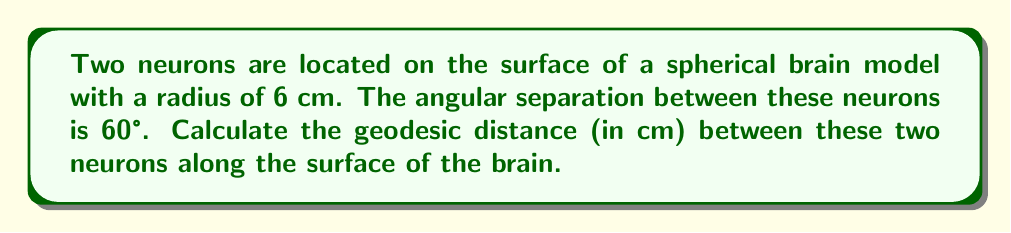Help me with this question. To solve this problem, we'll use the formula for the arc length on a sphere, which represents the geodesic distance between two points on a spherical surface.

Step 1: Recall the formula for arc length (s) on a sphere:
$$s = r\theta$$
Where:
- $r$ is the radius of the sphere
- $\theta$ is the central angle in radians

Step 2: Convert the given angle from degrees to radians:
$$\theta = 60° \times \frac{\pi}{180°} = \frac{\pi}{3} \text{ radians}$$

Step 3: Apply the arc length formula:
$$s = r\theta = 6 \text{ cm} \times \frac{\pi}{3} = 2\pi \text{ cm}$$

Step 4: Simplify the result:
$$s = 2\pi \text{ cm} \approx 6.28 \text{ cm}$$

Therefore, the geodesic distance between the two neurons on the spherical brain surface is $2\pi$ cm or approximately 6.28 cm.
Answer: $2\pi$ cm 